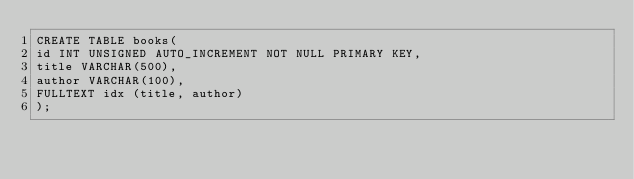<code> <loc_0><loc_0><loc_500><loc_500><_SQL_>CREATE TABLE books(
id INT UNSIGNED AUTO_INCREMENT NOT NULL PRIMARY KEY,
title VARCHAR(500),
author VARCHAR(100),
FULLTEXT idx (title, author)
);
</code> 